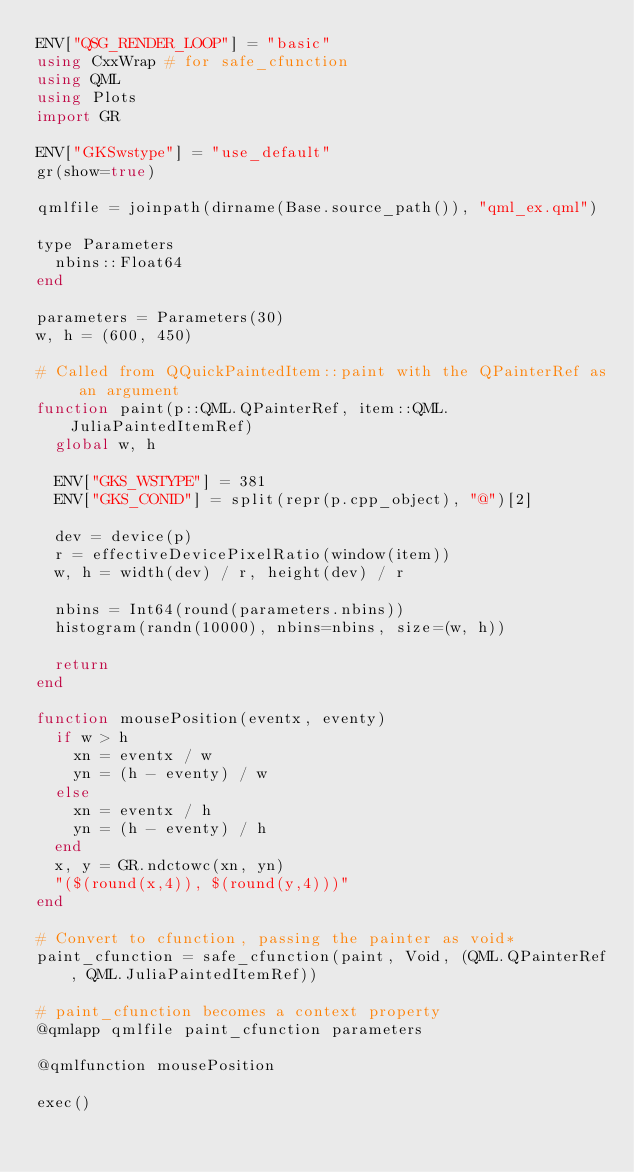<code> <loc_0><loc_0><loc_500><loc_500><_Julia_>ENV["QSG_RENDER_LOOP"] = "basic"
using CxxWrap # for safe_cfunction
using QML
using Plots
import GR

ENV["GKSwstype"] = "use_default"
gr(show=true)

qmlfile = joinpath(dirname(Base.source_path()), "qml_ex.qml")

type Parameters
  nbins::Float64
end

parameters = Parameters(30)
w, h = (600, 450)

# Called from QQuickPaintedItem::paint with the QPainterRef as an argument
function paint(p::QML.QPainterRef, item::QML.JuliaPaintedItemRef)
  global w, h

  ENV["GKS_WSTYPE"] = 381
  ENV["GKS_CONID"] = split(repr(p.cpp_object), "@")[2]

  dev = device(p)
  r = effectiveDevicePixelRatio(window(item))
  w, h = width(dev) / r, height(dev) / r

  nbins = Int64(round(parameters.nbins))
  histogram(randn(10000), nbins=nbins, size=(w, h))

  return
end

function mousePosition(eventx, eventy)
  if w > h
    xn = eventx / w
    yn = (h - eventy) / w
  else
    xn = eventx / h
    yn = (h - eventy) / h
  end
  x, y = GR.ndctowc(xn, yn)
  "($(round(x,4)), $(round(y,4)))"
end

# Convert to cfunction, passing the painter as void*
paint_cfunction = safe_cfunction(paint, Void, (QML.QPainterRef, QML.JuliaPaintedItemRef))

# paint_cfunction becomes a context property
@qmlapp qmlfile paint_cfunction parameters

@qmlfunction mousePosition

exec()
</code> 